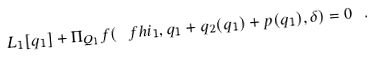Convert formula to latex. <formula><loc_0><loc_0><loc_500><loc_500>L _ { 1 } [ q _ { 1 } ] + \Pi _ { Q _ { 1 } } f ( \ f h i _ { 1 } , q _ { 1 } + q _ { 2 } ( q _ { 1 } ) + p ( q _ { 1 } ) , \delta ) = 0 \ .</formula> 